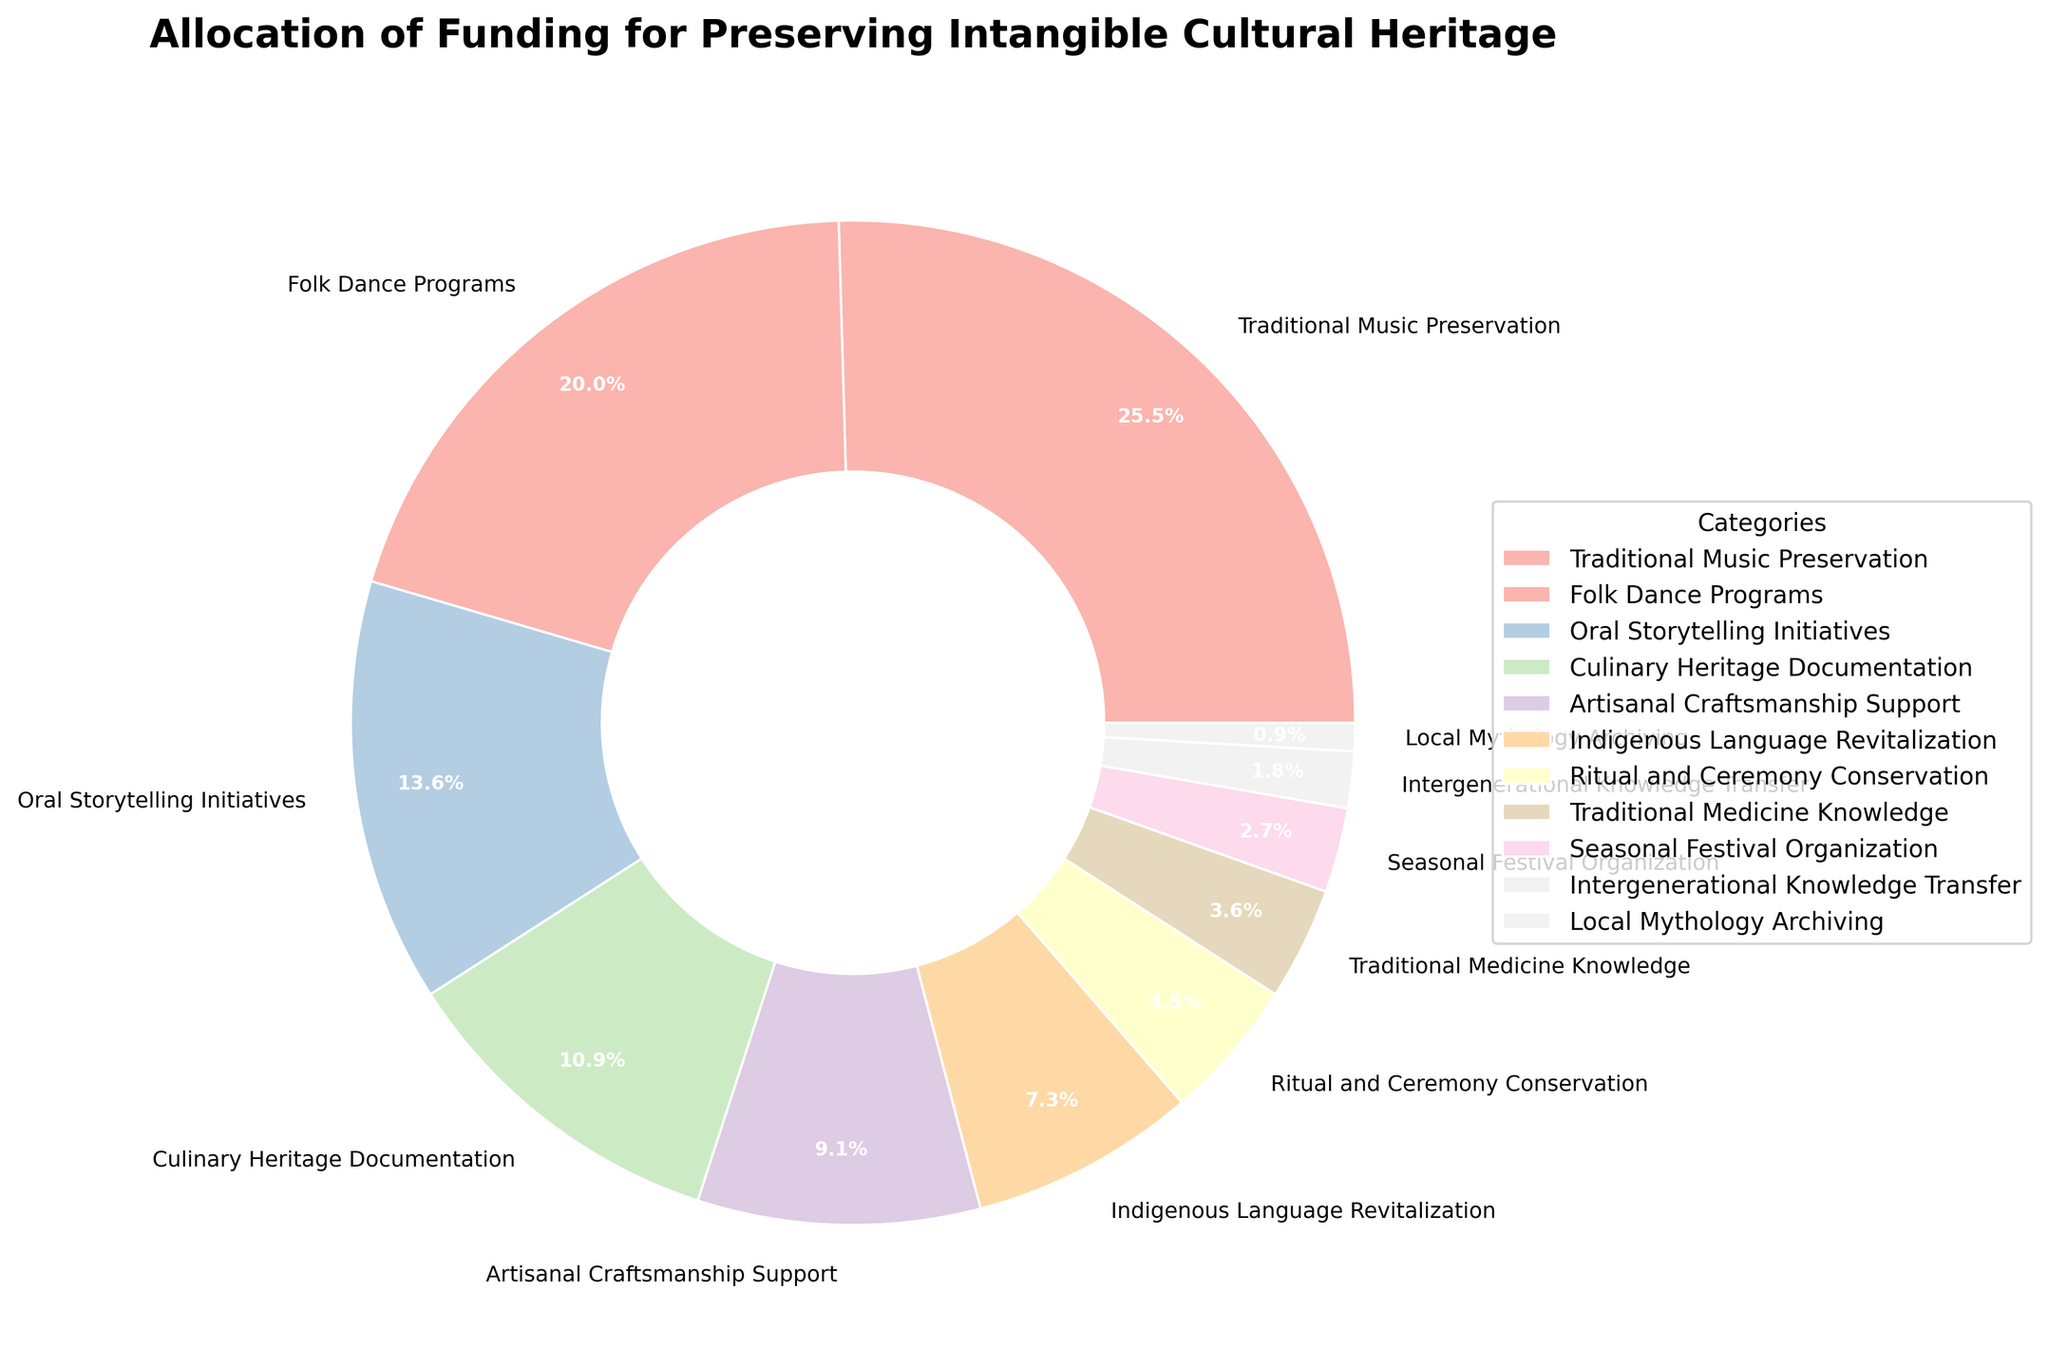What percentage of funding is allocated to Traditional Music Preservation? Identify the segment labeled "Traditional Music Preservation" and read the corresponding percentage.
Answer: 28% Which category receives the least funding? Identify the smallest segment of the pie chart and read its corresponding label.
Answer: Local Mythology Archiving How much more funding does Folk Dance Programs receive compared to Oral Storytelling Initiatives? Subtract the percentage of Oral Storytelling Initiatives from the percentage of Folk Dance Programs (22% - 15% = 7%).
Answer: 7% What’s the combined percentage of funding allocated for Culinary Heritage Documentation and Artisanal Craftsmanship Support? Add the percentages of Culinary Heritage Documentation (12%) and Artisanal Craftsmanship Support (10%) (12% + 10% = 22%).
Answer: 22% Are there more funds allocated to Indigenous Language Revitalization or Traditional Medicine Knowledge, and by how much? Compare the percentages of Indigenous Language Revitalization (8%) and Traditional Medicine Knowledge (4%). Subtract the smaller percentage from the larger one (8% - 4% = 4%).
Answer: Indigenous Language Revitalization by 4% What percentage of funding goes to the three smallest categories combined? Identify and add the percentages of the three smallest categories: Local Mythology Archiving (1%), Intergenerational Knowledge Transfer (2%), and Seasonal Festival Organization (3%) (1% + 2% + 3% = 6%).
Answer: 6% Which category receives less funding: Ritual and Ceremony Conservation or Culinary Heritage Documentation? Compare the percentages of Ritual and Ceremony Conservation (5%) and Culinary Heritage Documentation (12%).
Answer: Ritual and Ceremony Conservation What’s the difference between the funding for the highest and the lowest categories? Subtract the percentage of the lowest category (Local Mythology Archiving at 1%) from the highest category (Traditional Music Preservation at 28%) (28% - 1% = 27%).
Answer: 27% How many categories receive 10% or more of the total funding? Count the segments of the pie chart that have percentages of 10% or more: Traditional Music Preservation (28%), Folk Dance Programs (22%), Oral Storytelling Initiatives (15%), Culinary Heritage Documentation (12%), and Artisanal Craftsmanship Support (10%) (total of 5 categories).
Answer: 5 Which category is allocated the largest share of funding, and what color is it represented by? Identify the largest segment of the pie chart (Traditional Music Preservation at 28%) and observe its color (depends on the specific rendering of the chart).
Answer: Traditional Music Preservation and its specific color 